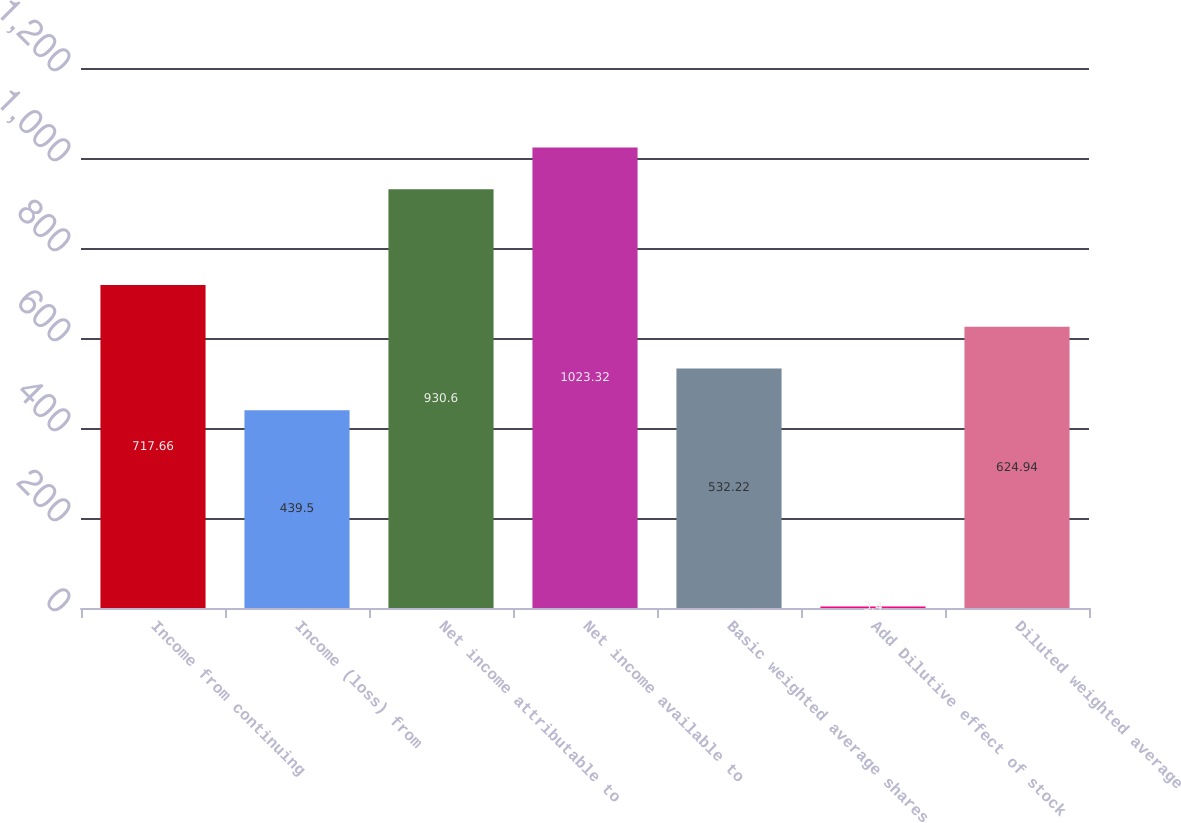Convert chart. <chart><loc_0><loc_0><loc_500><loc_500><bar_chart><fcel>Income from continuing<fcel>Income (loss) from<fcel>Net income attributable to<fcel>Net income available to<fcel>Basic weighted average shares<fcel>Add Dilutive effect of stock<fcel>Diluted weighted average<nl><fcel>717.66<fcel>439.5<fcel>930.6<fcel>1023.32<fcel>532.22<fcel>3.4<fcel>624.94<nl></chart> 